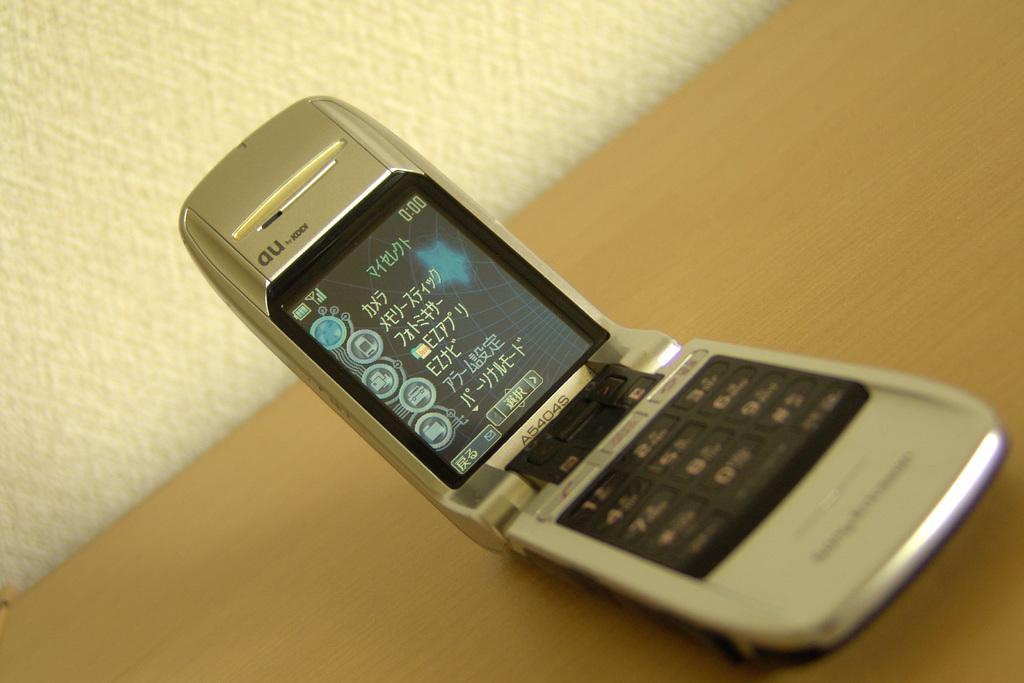Provide a one-sentence caption for the provided image. The time in the right hand corner of the cellphone screen is 0:00. 